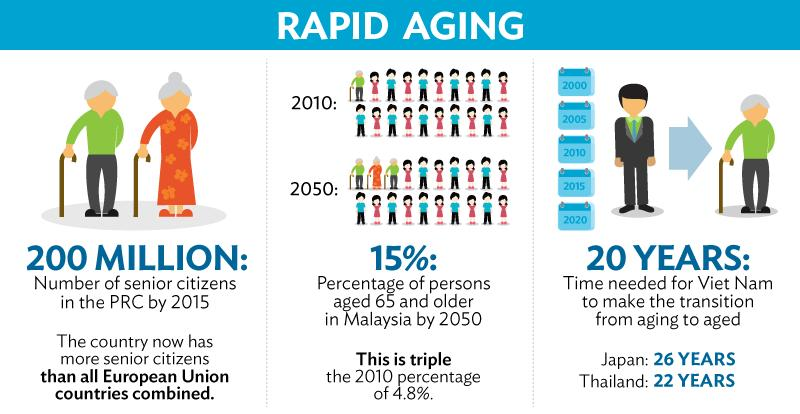Give some essential details in this illustration. By 2015, the number of senior citizens in the PCR was estimated to be approximately 200 million. 